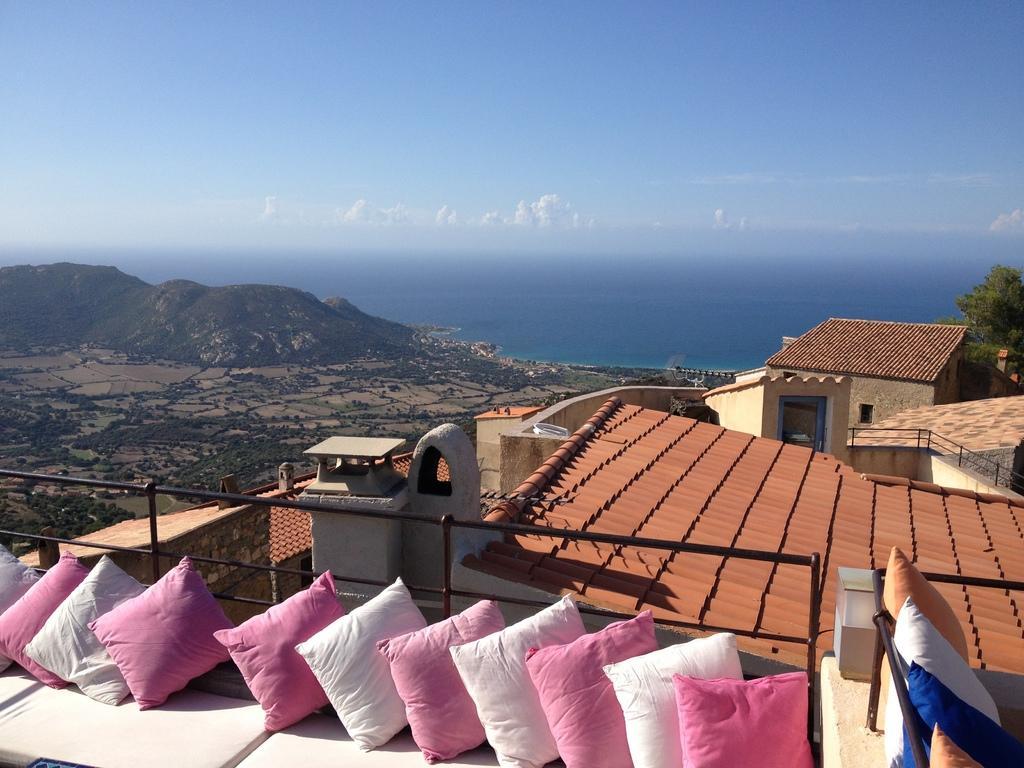Describe this image in one or two sentences. In this image we can see the buildings. Behind the buildings we can see trees, mountains and the water. At the bottom we can see the pillows. At the top we can see the sky. 